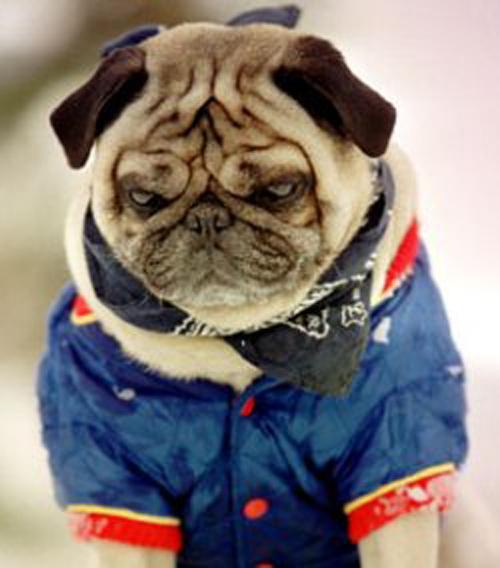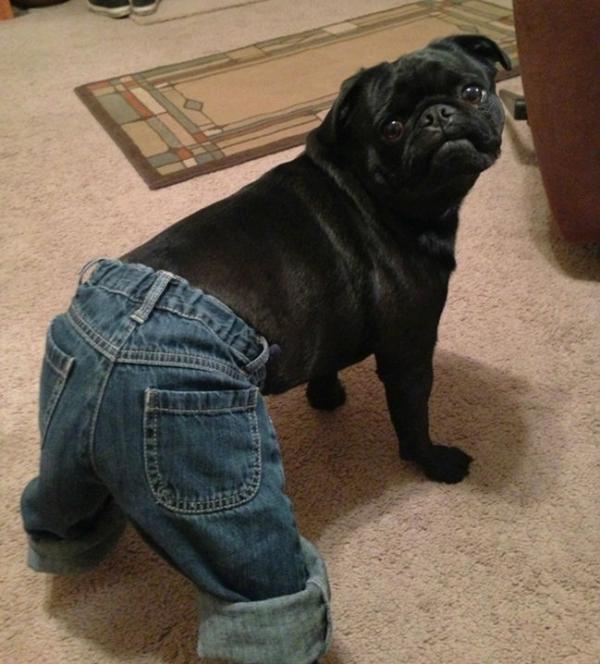The first image is the image on the left, the second image is the image on the right. Assess this claim about the two images: "Both dogs are being dressed in human like attire.". Correct or not? Answer yes or no. Yes. The first image is the image on the left, the second image is the image on the right. Given the left and right images, does the statement "One image shows a horizontal row of pug dogs that are not in costume." hold true? Answer yes or no. No. 